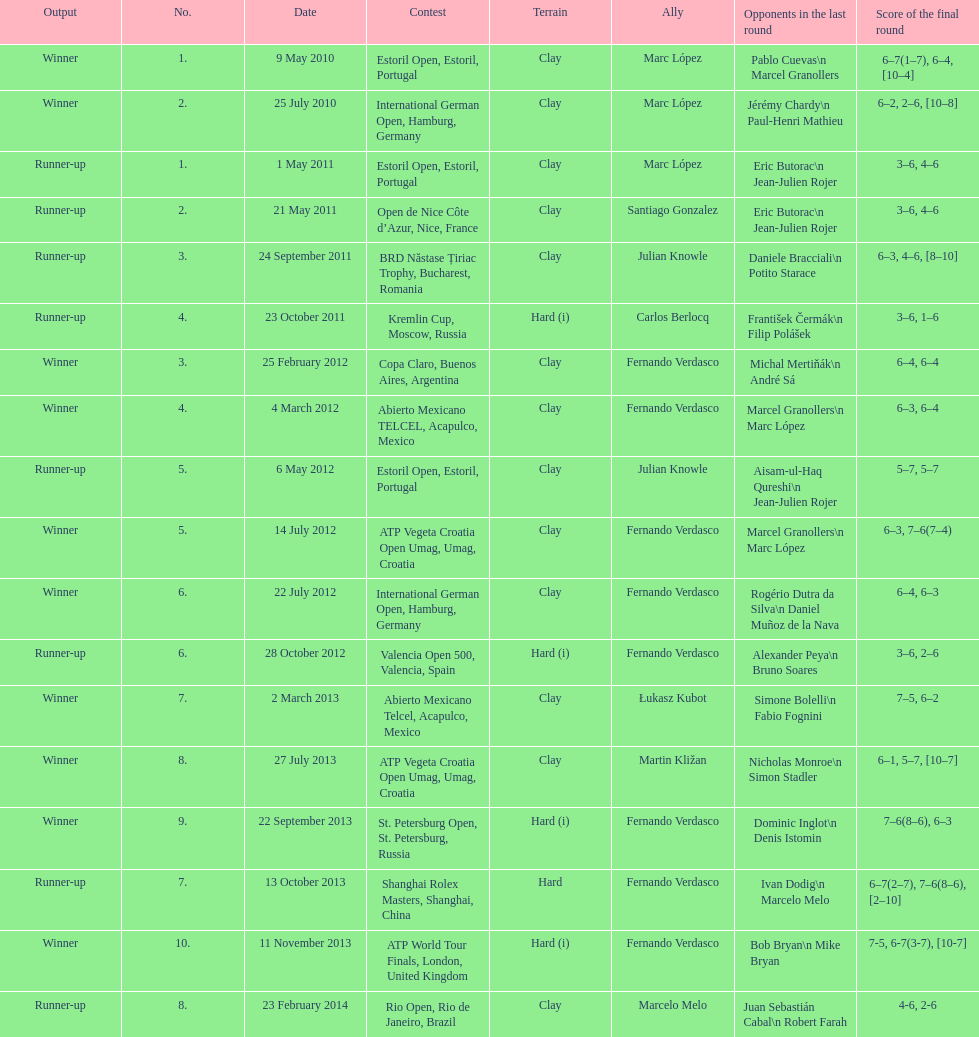Who won both the st.petersburg open and the atp world tour finals? Fernando Verdasco. 